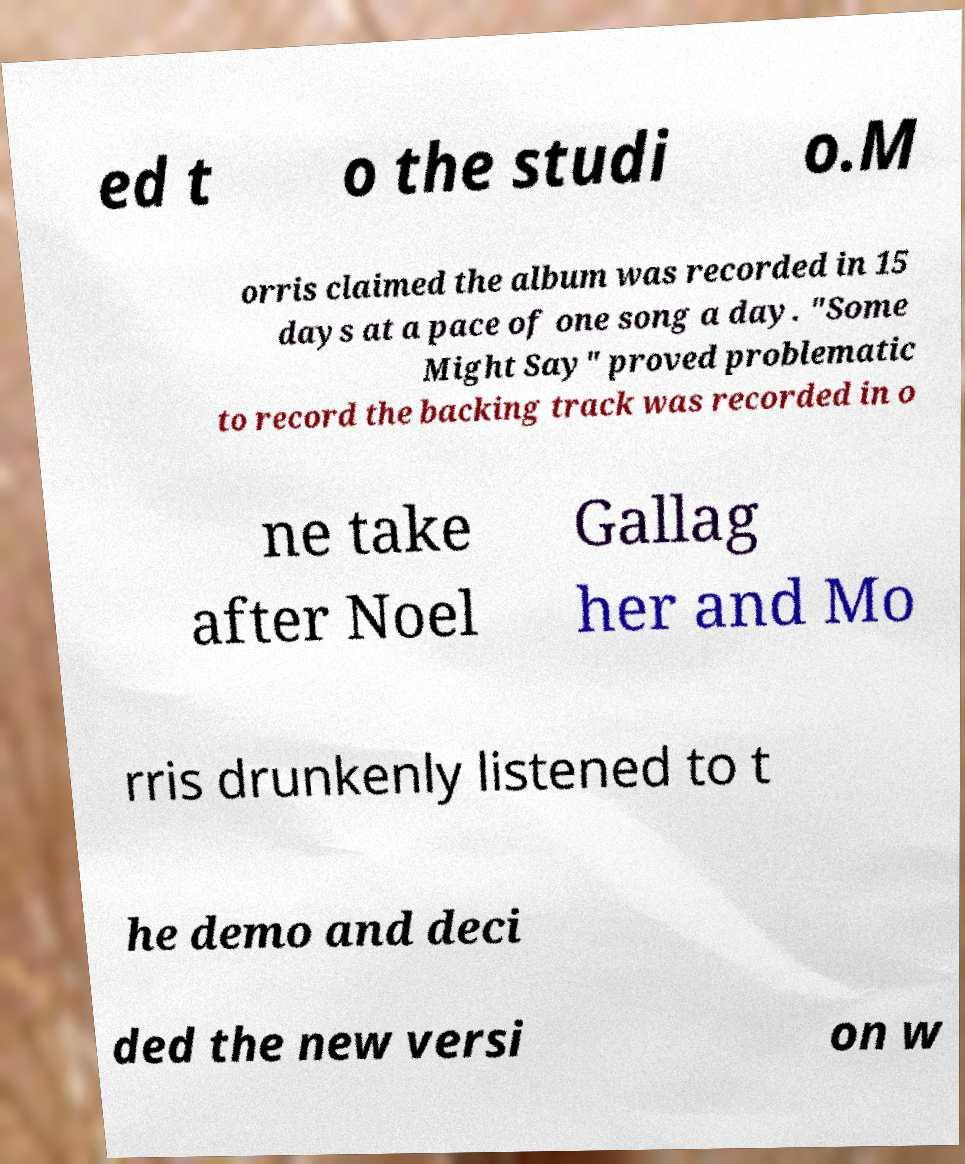I need the written content from this picture converted into text. Can you do that? ed t o the studi o.M orris claimed the album was recorded in 15 days at a pace of one song a day. "Some Might Say" proved problematic to record the backing track was recorded in o ne take after Noel Gallag her and Mo rris drunkenly listened to t he demo and deci ded the new versi on w 